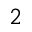Convert formula to latex. <formula><loc_0><loc_0><loc_500><loc_500>_ { 2 }</formula> 